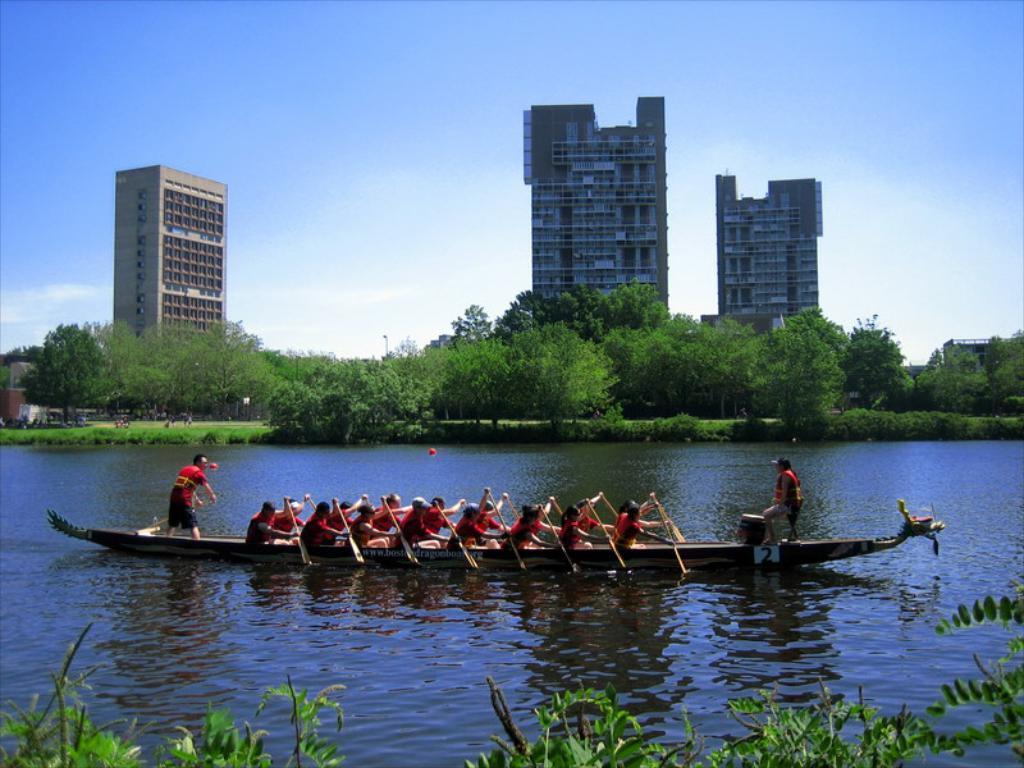How would you summarize this image in a sentence or two? In this image I can see the boat on the water. I can see many people sitting in the boat. On both sides of the water I can see the plants. In the background I can see many trees, buildings, clouds and the sky. 